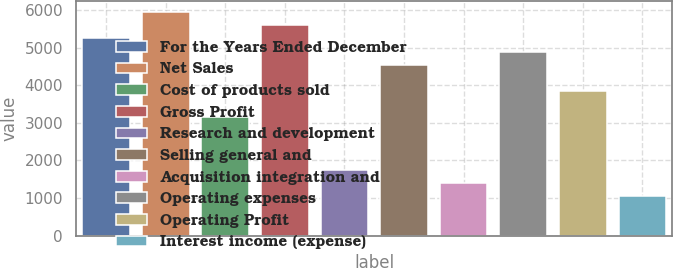Convert chart. <chart><loc_0><loc_0><loc_500><loc_500><bar_chart><fcel>For the Years Ended December<fcel>Net Sales<fcel>Cost of products sold<fcel>Gross Profit<fcel>Research and development<fcel>Selling general and<fcel>Acquisition integration and<fcel>Operating expenses<fcel>Operating Profit<fcel>Interest income (expense)<nl><fcel>5242.85<fcel>5941.83<fcel>3145.91<fcel>5592.34<fcel>1747.95<fcel>4543.87<fcel>1398.46<fcel>4893.36<fcel>3844.89<fcel>1048.97<nl></chart> 